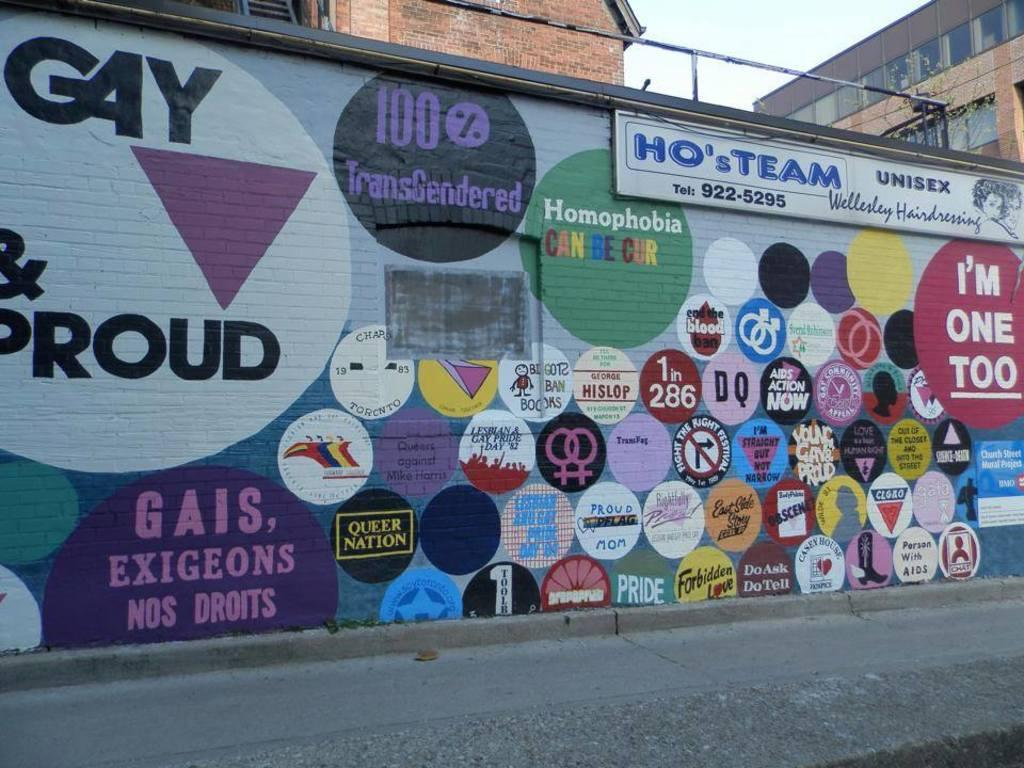Provide a one-sentence caption for the provided image. A painted wall on the side of a building that reads HO's TEAM. 